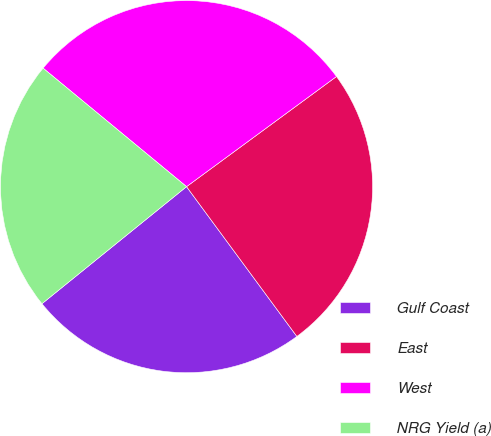<chart> <loc_0><loc_0><loc_500><loc_500><pie_chart><fcel>Gulf Coast<fcel>East<fcel>West<fcel>NRG Yield (a)<nl><fcel>24.27%<fcel>24.98%<fcel>28.93%<fcel>21.82%<nl></chart> 